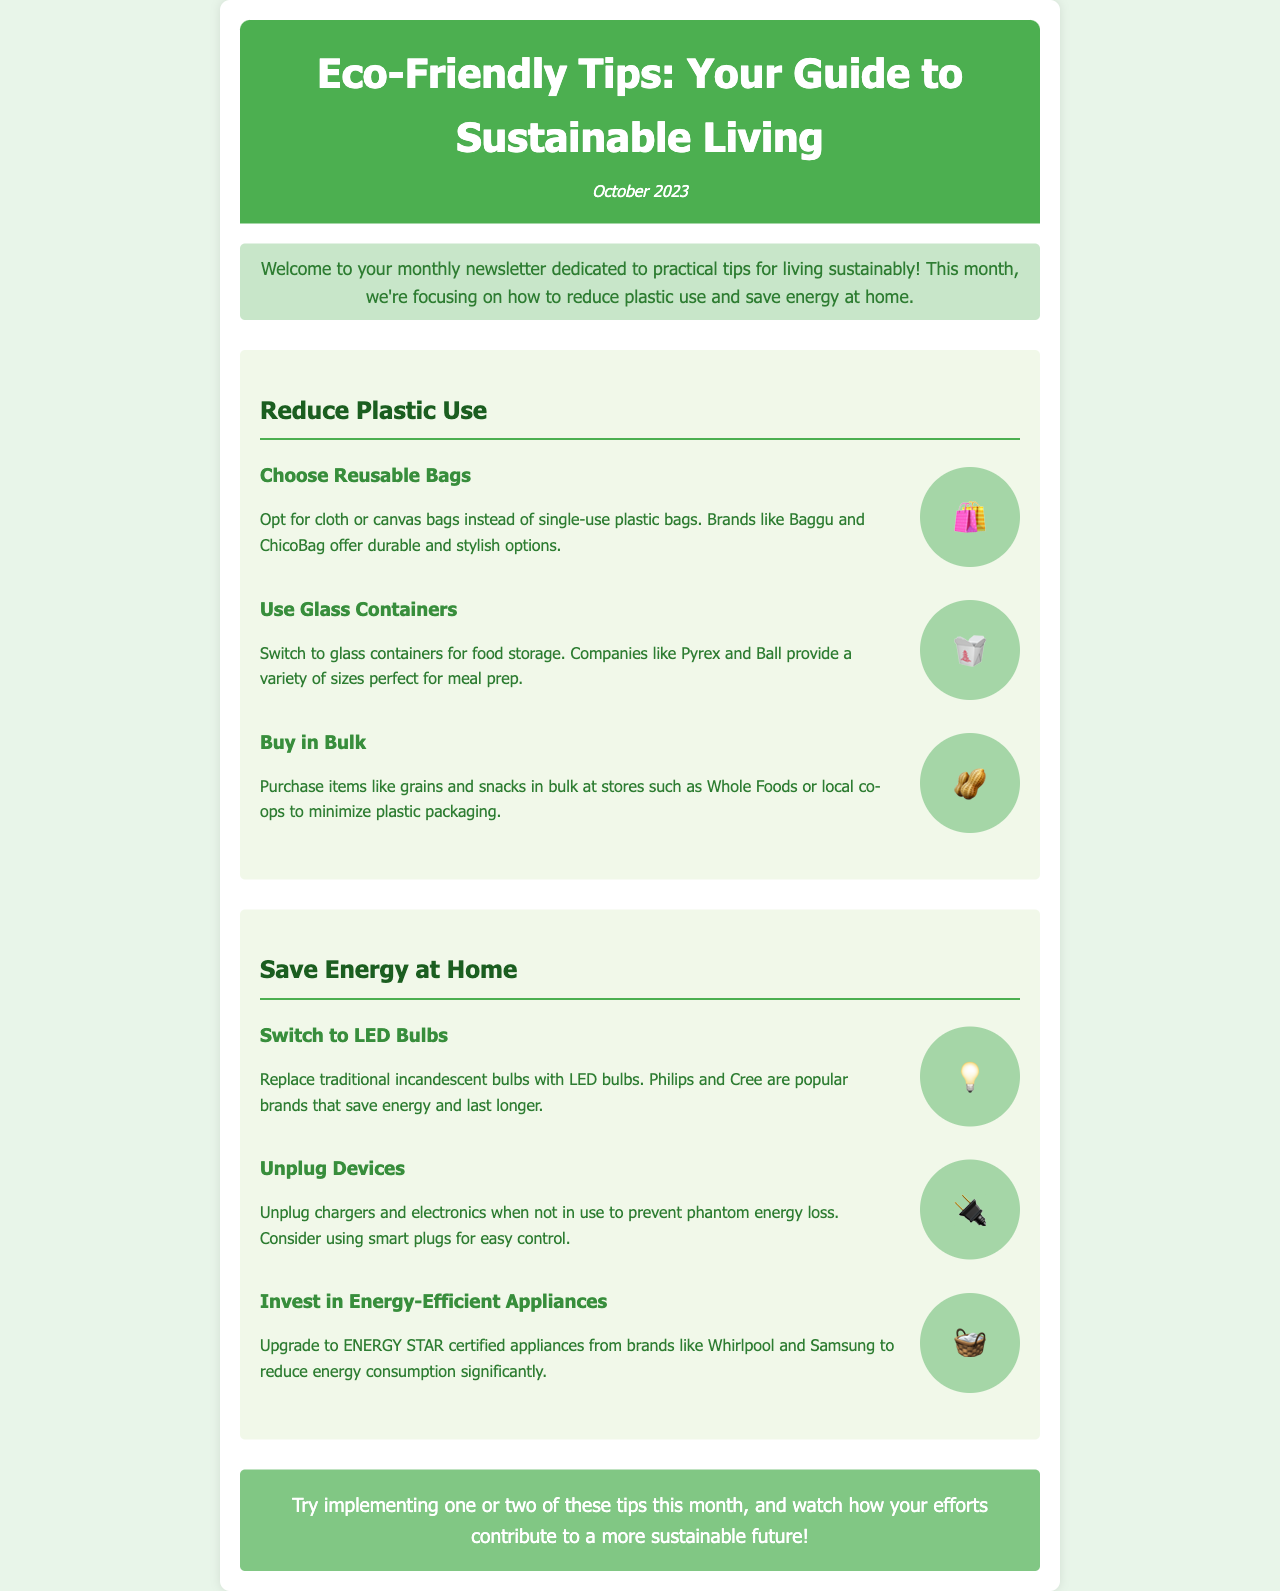What is the title of the newsletter? The title is clearly mentioned in the header section of the document.
Answer: Eco-Friendly Tips: Your Guide to Sustainable Living What month is this newsletter published? The publication date is indicated in the date section of the header.
Answer: October 2023 What is one recommended alternative to single-use plastic bags? The newsletter lists tips under the section for reducing plastic use.
Answer: Reusable bags Which type of bulbs should be switched to save energy? The energy-saving tips specify which bulbs to replace in the section on saving energy at home.
Answer: LED bulbs Which company brands are mentioned for glass containers? The document lists brands associated with tips to provide specific recommendations for products.
Answer: Pyrex and Ball What are two methods suggested for reducing plastic use? The section discusses multiple strategies, which requires reasoning through the text.
Answer: Reusable bags and glass containers How many tips are provided for saving energy at home? The number of tips can be retrieved by counting the suggestions listed in that section.
Answer: Three What type of appliances should one invest in to reduce energy consumption? The document points out specific types of appliances to upgrade to in the energy-saving section.
Answer: Energy-efficient appliances What type of newsletter is this document? The structure and content of the document indicate its intended purpose clearly.
Answer: Monthly newsletter 